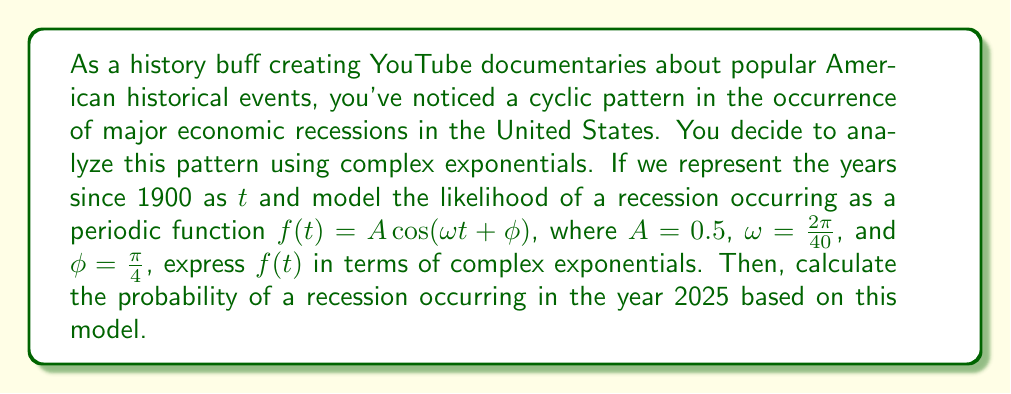Show me your answer to this math problem. To solve this problem, we'll follow these steps:

1) First, recall Euler's formula: $e^{ix} = \cos(x) + i\sin(x)$

2) We can express $\cos(x)$ in terms of complex exponentials:
   $$\cos(x) = \frac{e^{ix} + e^{-ix}}{2}$$

3) Our function is $f(t) = A\cos(\omega t + \phi)$, where $A = 0.5$, $\omega = \frac{2\pi}{40}$, and $\phi = \frac{\pi}{4}$

4) Substituting these values and using the complex exponential form:

   $$f(t) = 0.5 \cdot \frac{e^{i(\frac{2\pi}{40}t + \frac{\pi}{4})} + e^{-i(\frac{2\pi}{40}t + \frac{\pi}{4})}}{2}$$

5) Simplifying:

   $$f(t) = 0.25(e^{i(\frac{\pi}{20}t + \frac{\pi}{4})} + e^{-i(\frac{\pi}{20}t + \frac{\pi}{4})})$$

6) To find the probability for 2025, we need to calculate $t$:
   2025 - 1900 = 125 years

7) Substituting $t = 125$ into our function:

   $$f(125) = 0.25(e^{i(\frac{125\pi}{20} + \frac{\pi}{4})} + e^{-i(\frac{125\pi}{20} + \frac{\pi}{4})})$$

8) Simplifying the exponents:

   $$f(125) = 0.25(e^{i(\frac{25\pi}{4} + \frac{\pi}{4})} + e^{-i(\frac{25\pi}{4} + \frac{\pi}{4})})$$
   $$f(125) = 0.25(e^{i\frac{26\pi}{4}} + e^{-i\frac{26\pi}{4}})$$

9) Recall that $e^{i\pi} = -1$, so $e^{i\frac{26\pi}{4}} = e^{i(\frac{24\pi}{4} + \frac{\pi}{2})} = i$

10) Therefore:

    $$f(125) = 0.25(i + (-i)) = 0$$

This means that according to our model, the probability of a recession in 2025 is 0.
Answer: The function expressed in terms of complex exponentials is:
$$f(t) = 0.25(e^{i(\frac{\pi}{20}t + \frac{\pi}{4})} + e^{-i(\frac{\pi}{20}t + \frac{\pi}{4})})$$

The probability of a recession occurring in 2025 based on this model is 0. 